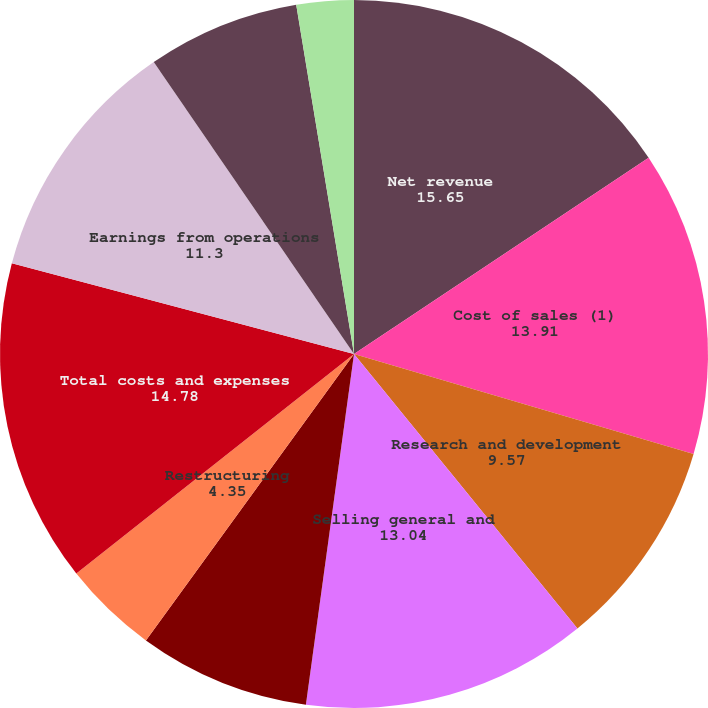Convert chart to OTSL. <chart><loc_0><loc_0><loc_500><loc_500><pie_chart><fcel>Net revenue<fcel>Cost of sales (1)<fcel>Research and development<fcel>Selling general and<fcel>Amortization of purchased<fcel>Restructuring<fcel>Total costs and expenses<fcel>Earnings from operations<fcel>Interest and other net<fcel>(Losses) gains on investments<nl><fcel>15.65%<fcel>13.91%<fcel>9.57%<fcel>13.04%<fcel>7.83%<fcel>4.35%<fcel>14.78%<fcel>11.3%<fcel>6.96%<fcel>2.61%<nl></chart> 